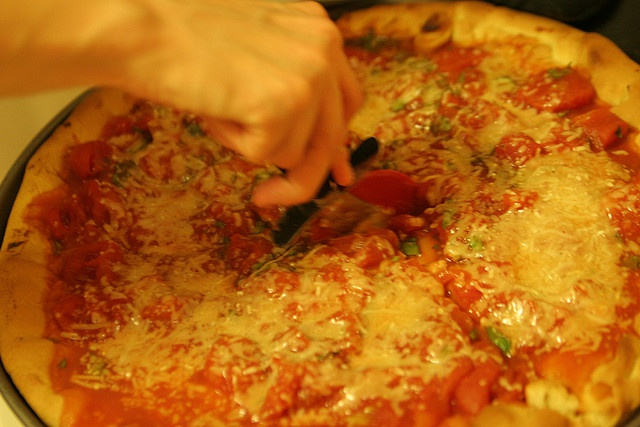Describe the objects in this image and their specific colors. I can see pizza in orange, red, and maroon tones and people in orange, red, and brown tones in this image. 